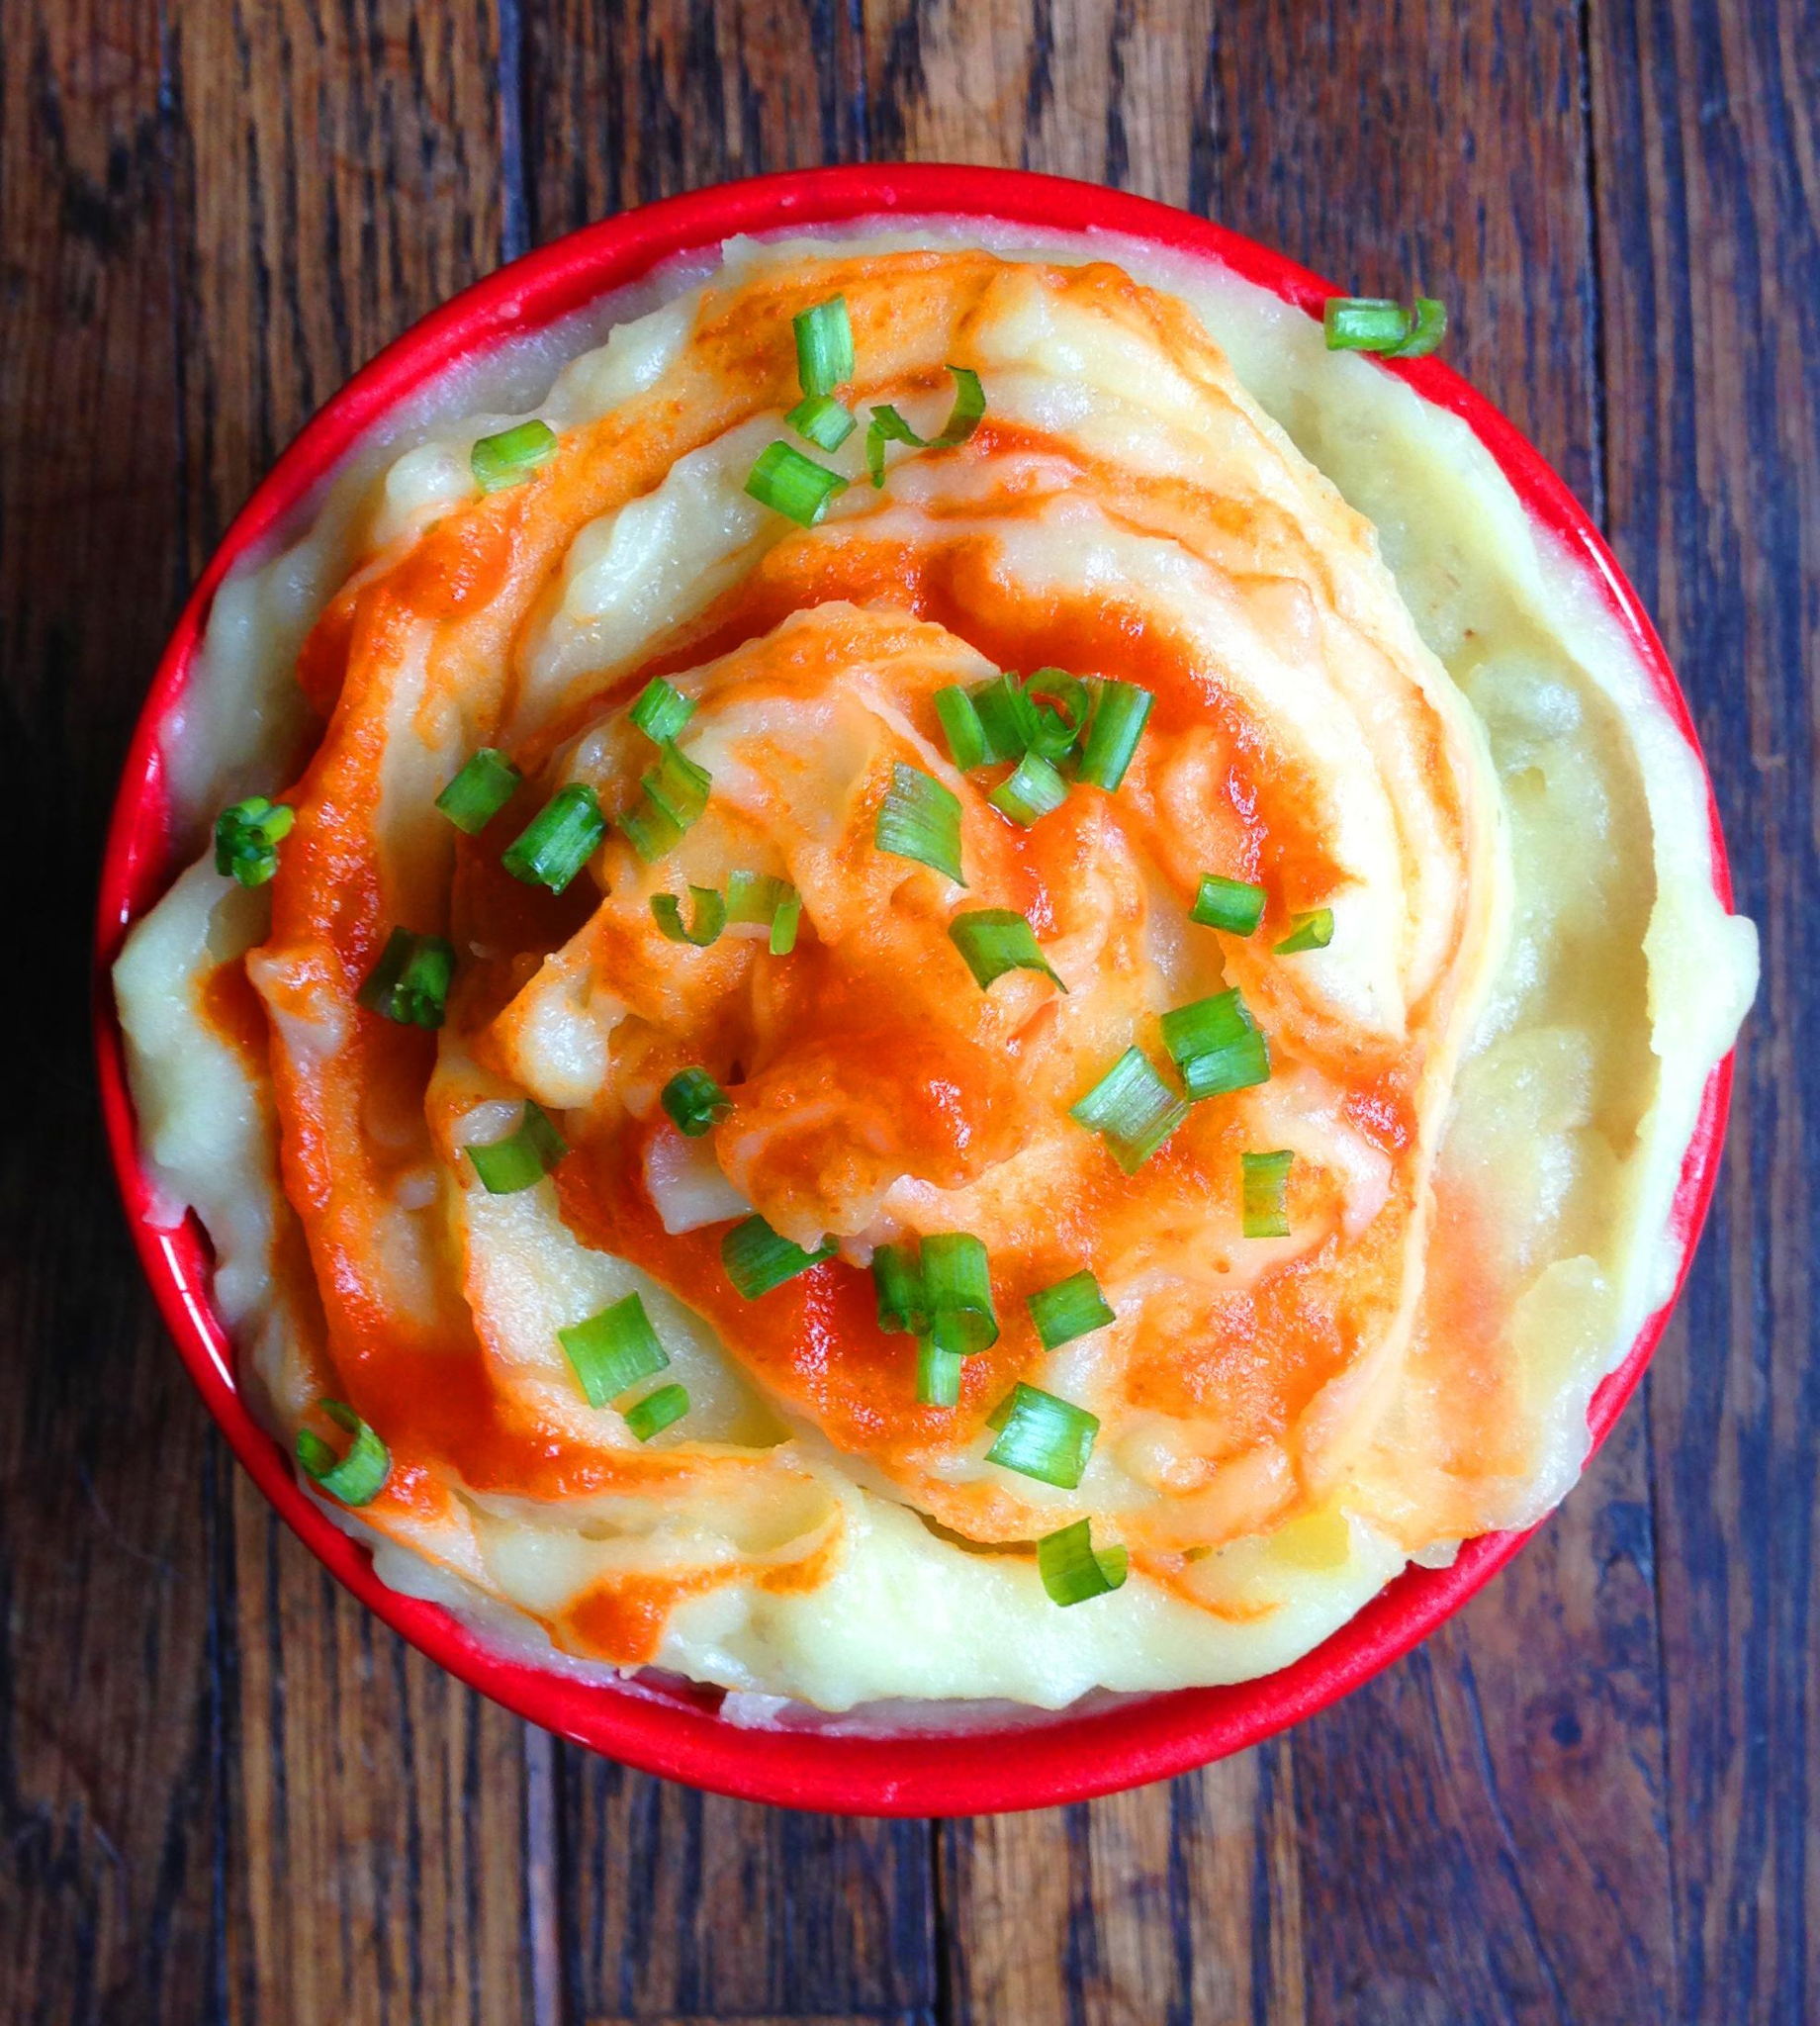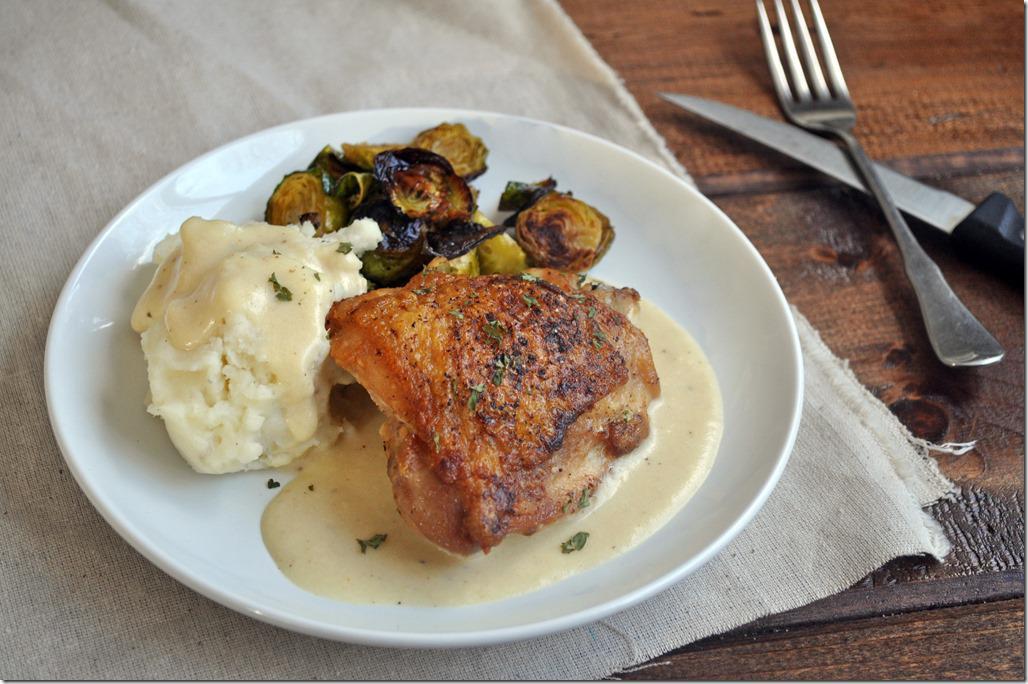The first image is the image on the left, the second image is the image on the right. Considering the images on both sides, is "A dish featuring mashed potatoes with gravy has a bright red rim." valid? Answer yes or no. Yes. The first image is the image on the left, the second image is the image on the right. For the images displayed, is the sentence "In one image there is one or more utensils on the plate." factually correct? Answer yes or no. No. 